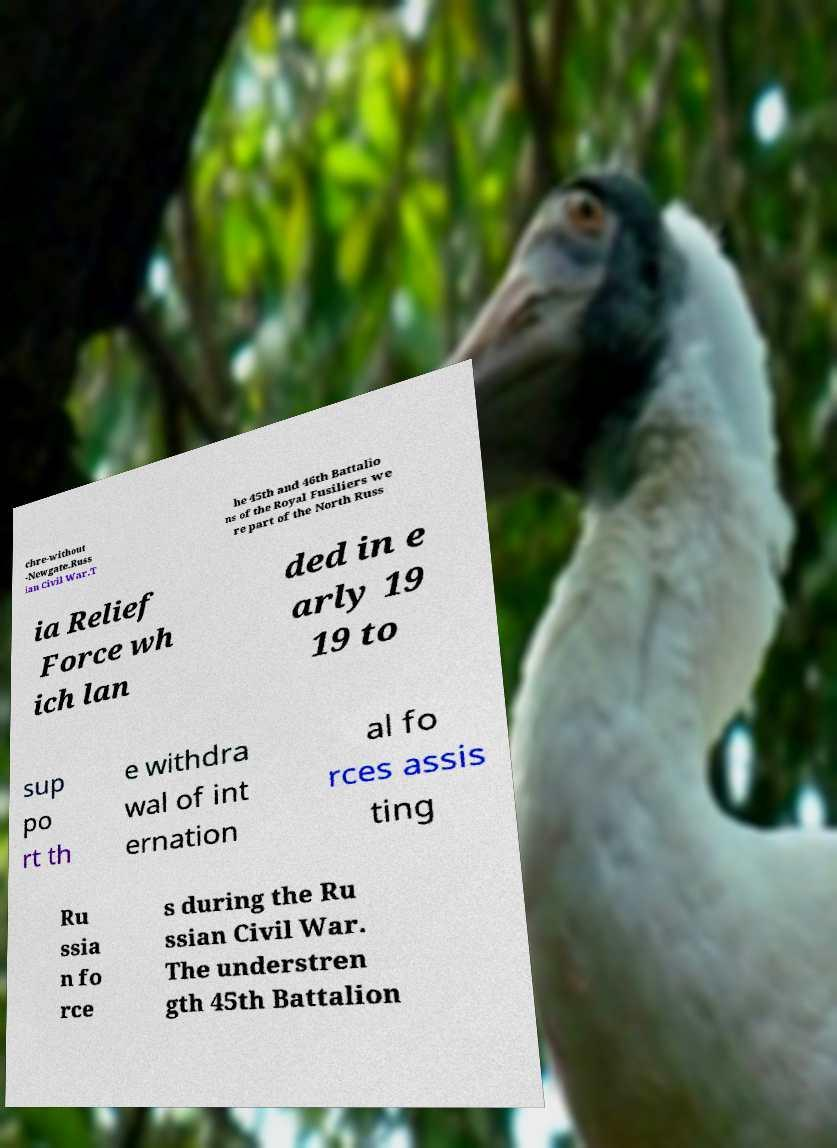Please read and relay the text visible in this image. What does it say? chre-without -Newgate.Russ ian Civil War.T he 45th and 46th Battalio ns of the Royal Fusiliers we re part of the North Russ ia Relief Force wh ich lan ded in e arly 19 19 to sup po rt th e withdra wal of int ernation al fo rces assis ting Ru ssia n fo rce s during the Ru ssian Civil War. The understren gth 45th Battalion 